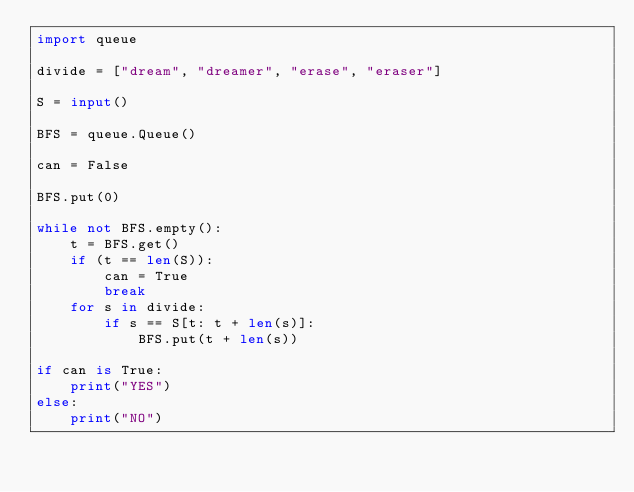<code> <loc_0><loc_0><loc_500><loc_500><_Python_>import queue

divide = ["dream", "dreamer", "erase", "eraser"]

S = input()

BFS = queue.Queue()

can = False

BFS.put(0)

while not BFS.empty():
    t = BFS.get()
    if (t == len(S)):
        can = True
        break
    for s in divide:
        if s == S[t: t + len(s)]:
            BFS.put(t + len(s))

if can is True:
    print("YES")
else:
    print("NO")</code> 